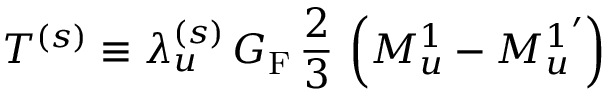<formula> <loc_0><loc_0><loc_500><loc_500>T ^ { ( s ) } \equiv \lambda _ { u } ^ { ( s ) } \, G _ { F } \, \frac { 2 } { 3 } \, \left ( M _ { u } ^ { 1 } - { M _ { u } ^ { 1 } } ^ { \prime } \right )</formula> 